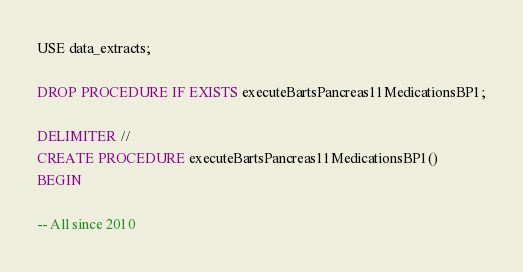Convert code to text. <code><loc_0><loc_0><loc_500><loc_500><_SQL_>USE data_extracts;

DROP PROCEDURE IF EXISTS executeBartsPancreas11MedicationsBP1;

DELIMITER //
CREATE PROCEDURE executeBartsPancreas11MedicationsBP1()
BEGIN

-- All since 2010
</code> 